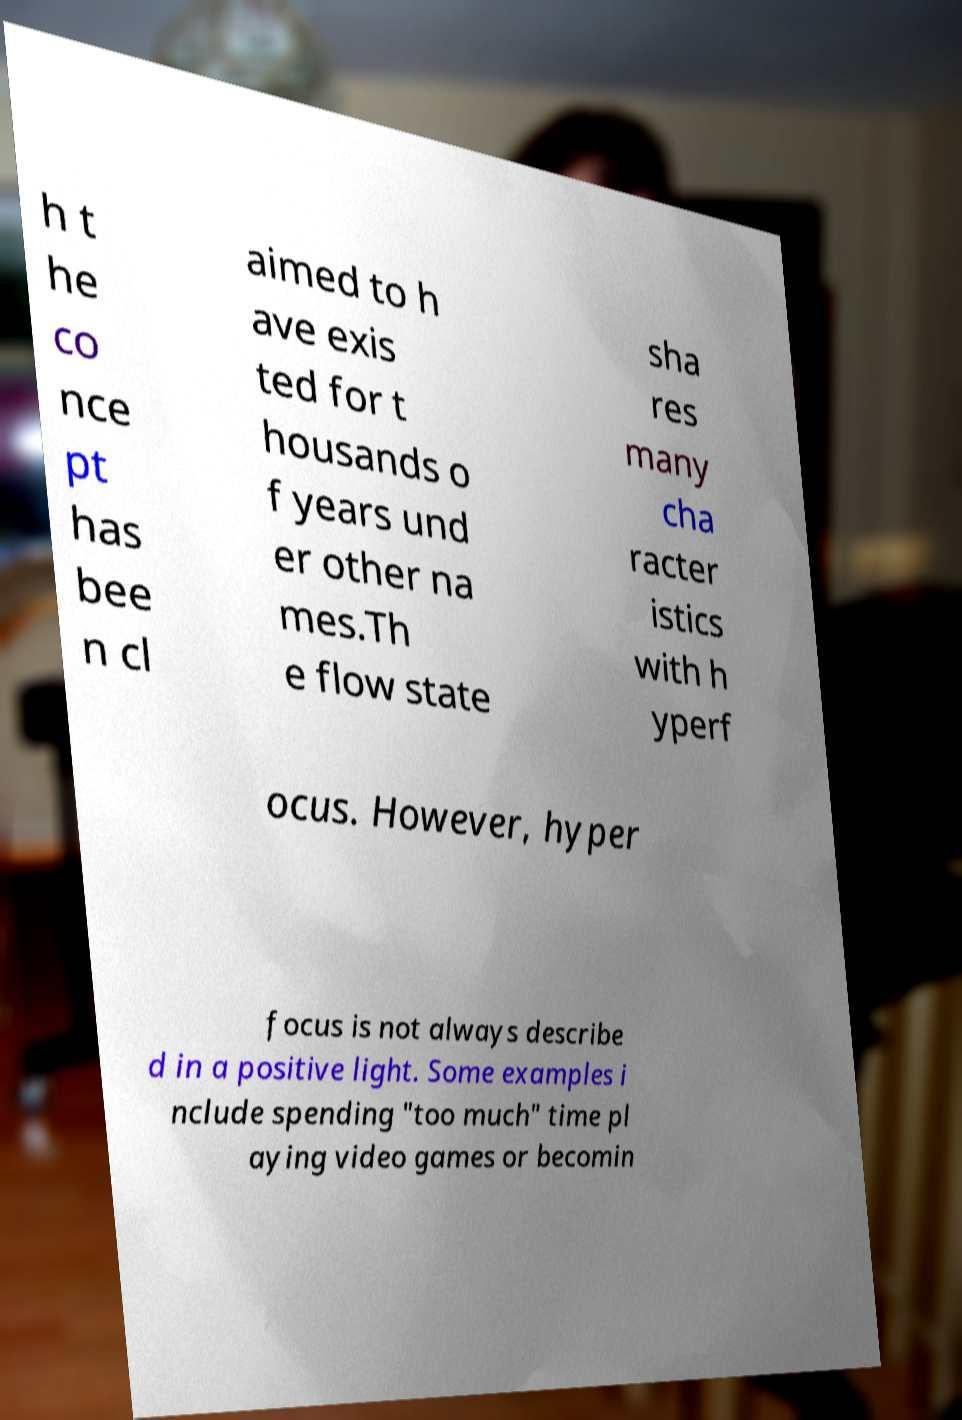I need the written content from this picture converted into text. Can you do that? h t he co nce pt has bee n cl aimed to h ave exis ted for t housands o f years und er other na mes.Th e flow state sha res many cha racter istics with h yperf ocus. However, hyper focus is not always describe d in a positive light. Some examples i nclude spending "too much" time pl aying video games or becomin 